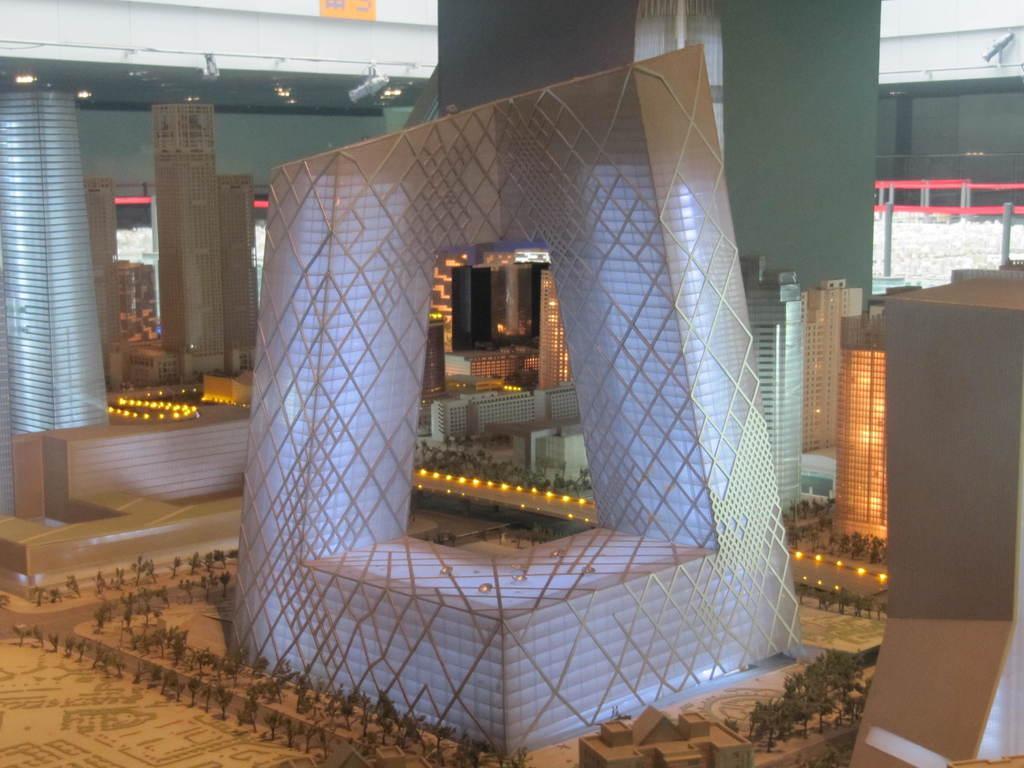Can you describe this image briefly? In the picture I can see toys of buildings, trees and some other objects on the ground. 